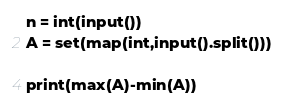Convert code to text. <code><loc_0><loc_0><loc_500><loc_500><_Python_>n = int(input())
A = set(map(int,input().split()))

print(max(A)-min(A))
</code> 